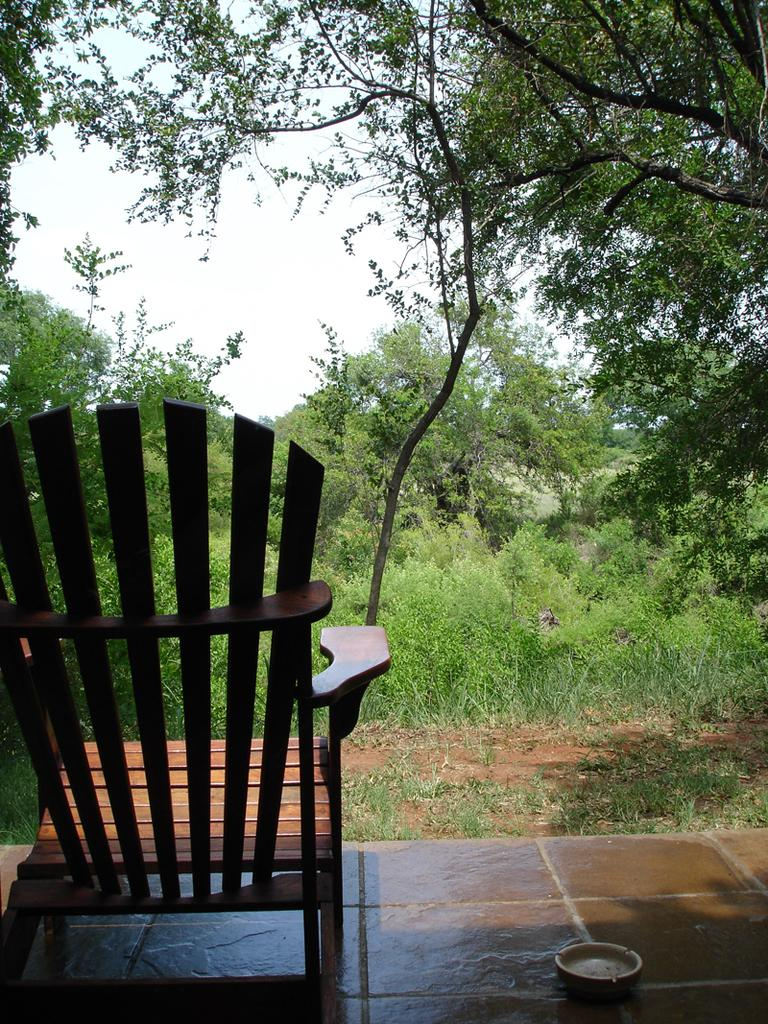What type of furniture is present in the image? There is a chair in the image. What type of natural environment is visible in the image? There is grass, plants, trees, and the sky visible in the image. What type of advertisement can be seen on the chair in the image? There is no advertisement present on the chair in the image. What committee is responsible for maintaining the plants and trees in the image? There is no information about a committee responsible for maintaining the plants and trees in the image. 